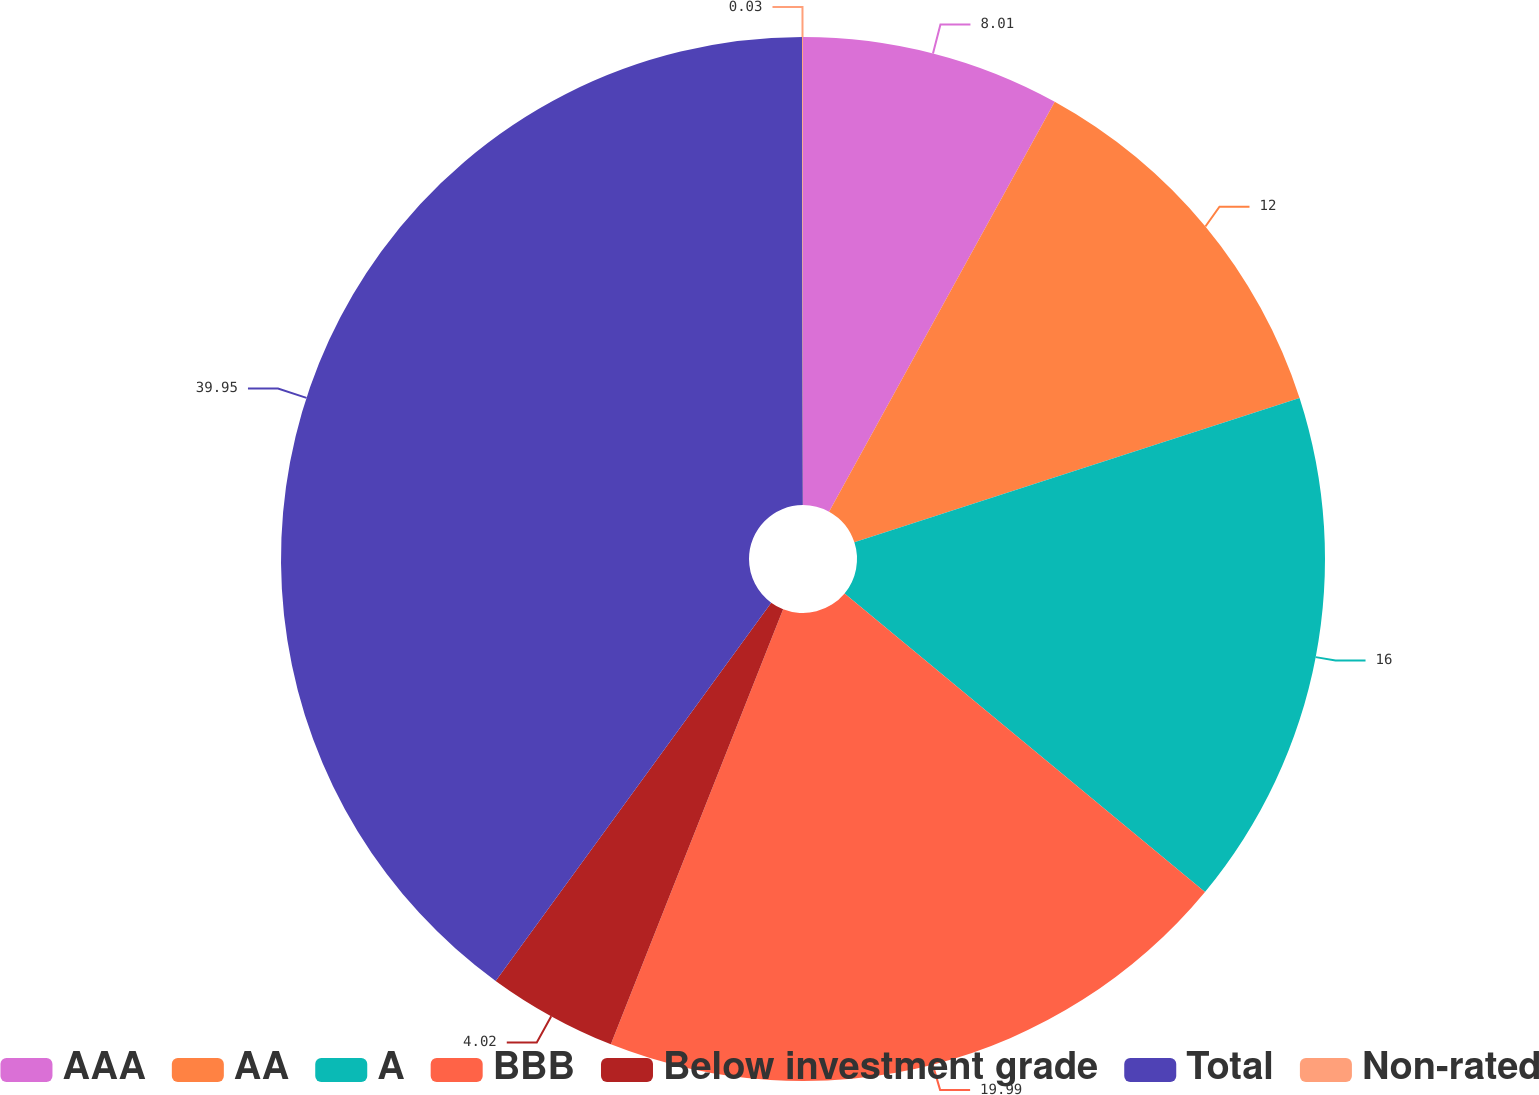Convert chart to OTSL. <chart><loc_0><loc_0><loc_500><loc_500><pie_chart><fcel>AAA<fcel>AA<fcel>A<fcel>BBB<fcel>Below investment grade<fcel>Total<fcel>Non-rated<nl><fcel>8.01%<fcel>12.0%<fcel>16.0%<fcel>19.99%<fcel>4.02%<fcel>39.95%<fcel>0.03%<nl></chart> 